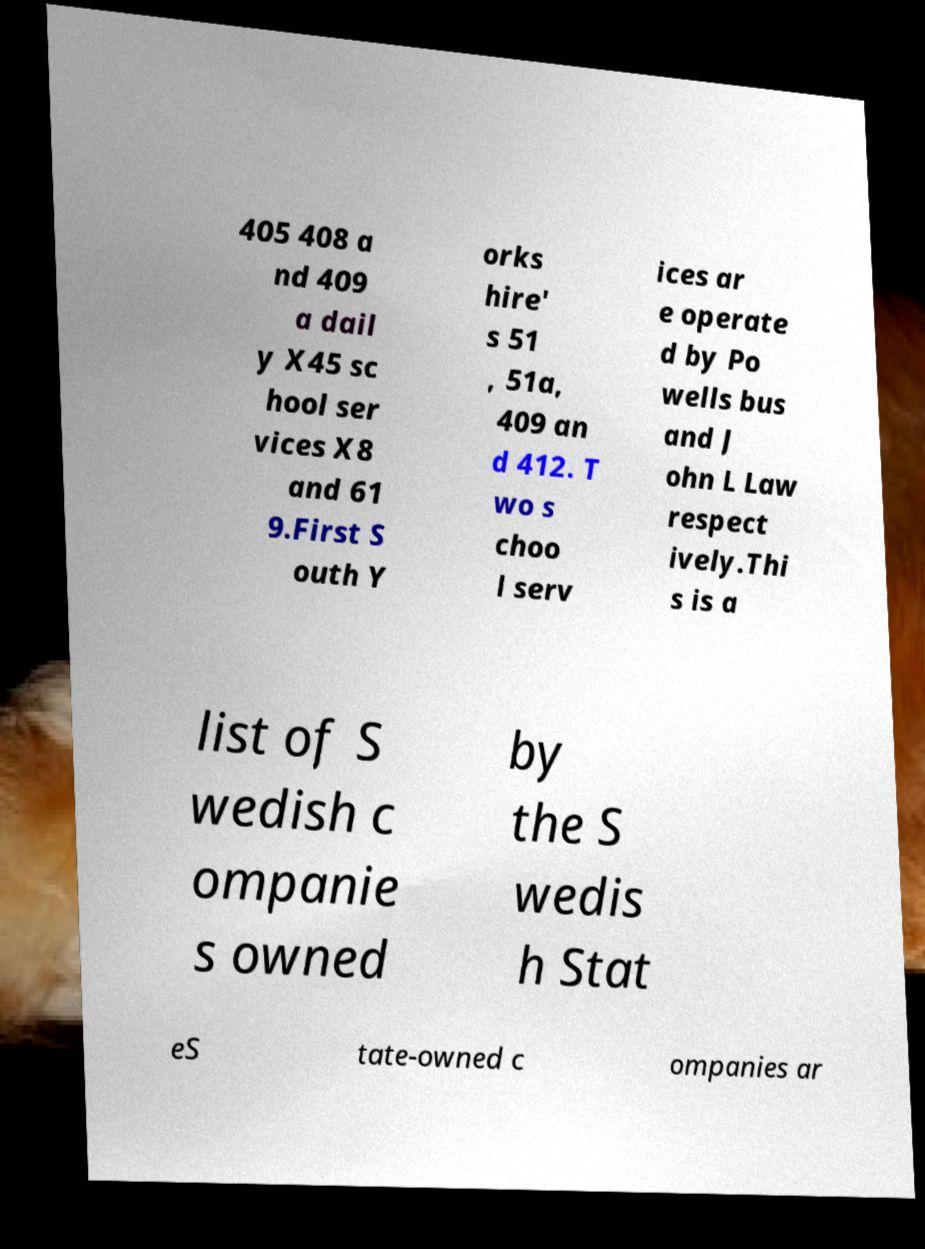Could you assist in decoding the text presented in this image and type it out clearly? 405 408 a nd 409 a dail y X45 sc hool ser vices X8 and 61 9.First S outh Y orks hire' s 51 , 51a, 409 an d 412. T wo s choo l serv ices ar e operate d by Po wells bus and J ohn L Law respect ively.Thi s is a list of S wedish c ompanie s owned by the S wedis h Stat eS tate-owned c ompanies ar 